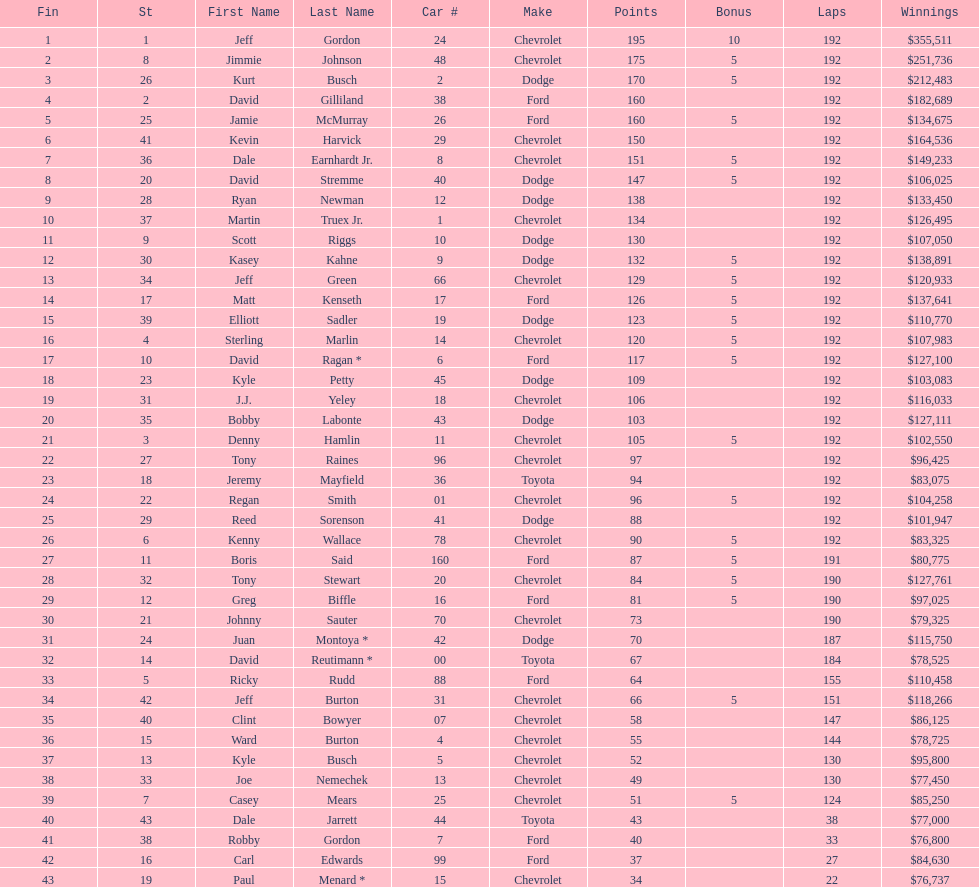Who got the most bonus points? Jeff Gordon. 